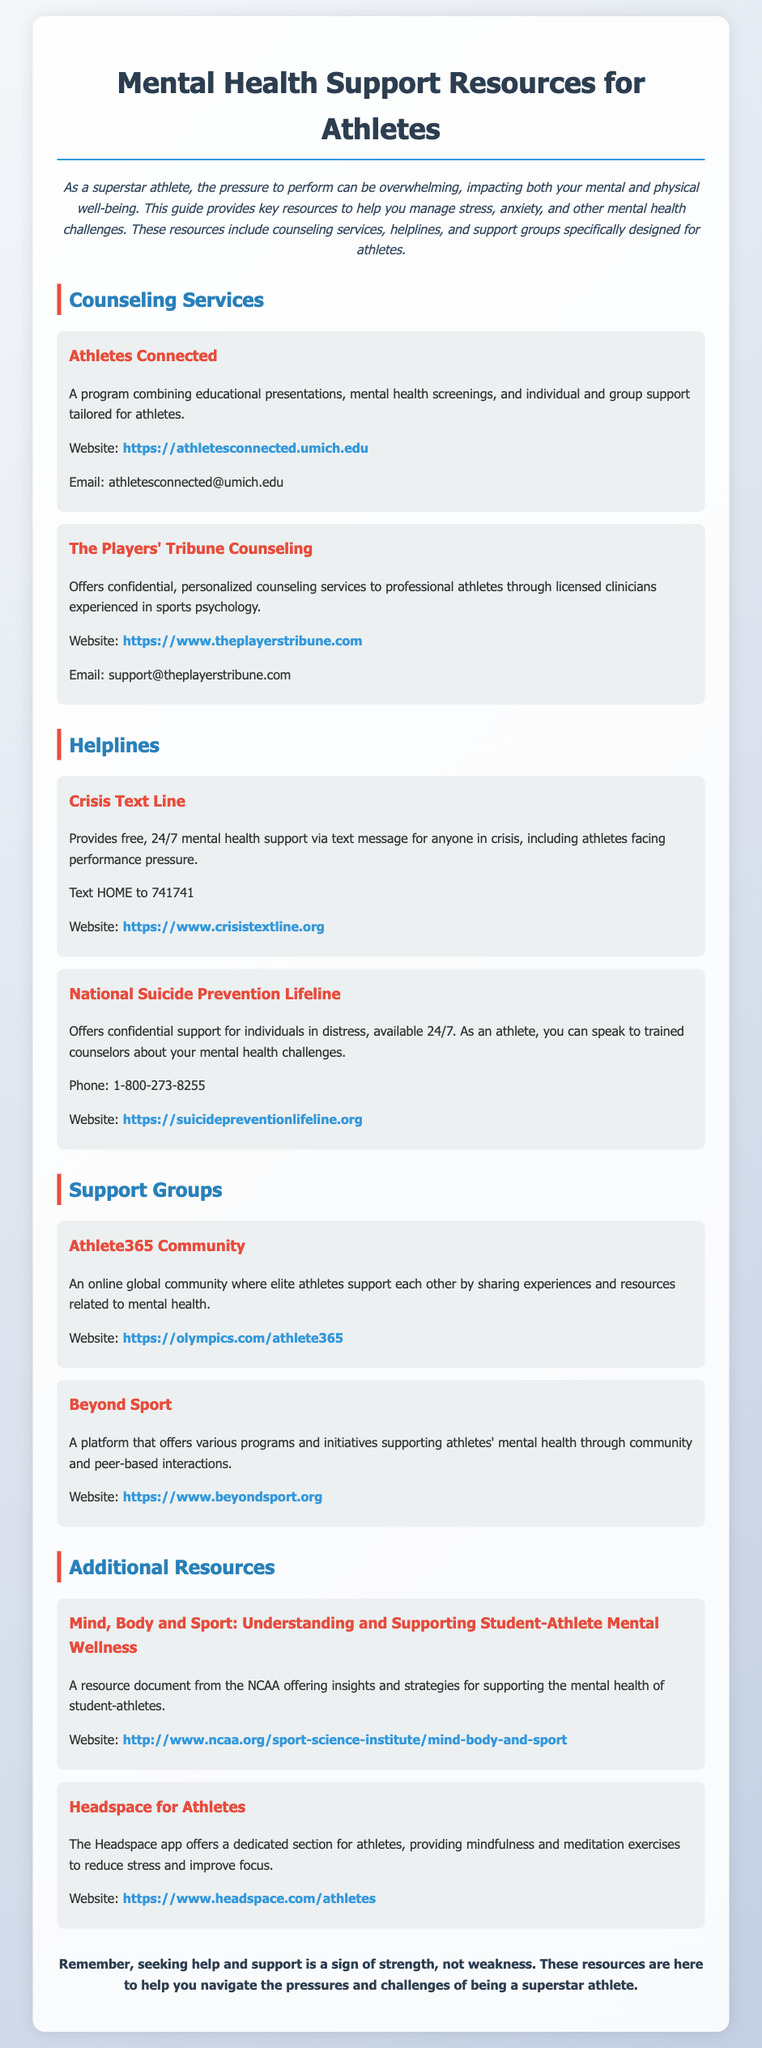what is the name of the program that combines educational presentations and support for athletes? The program focusing on educational presentations and support for athletes is called "Athletes Connected."
Answer: Athletes Connected what is the contact email for The Players' Tribune Counseling? The contact email for the counseling service is provided within the document.
Answer: support@theplayerstribune.com what is the phone number for the National Suicide Prevention Lifeline? The document specifies the phone number for the helpline as part of its support resources.
Answer: 1-800-273-8255 which organization offers a global community for elite athletes? The document mentions an online community platform specifically for elite athletes.
Answer: Athlete365 Community what service does the Crisis Text Line provide? The document describes the Crisis Text Line as offering a specific type of support for individuals in crisis.
Answer: 24/7 mental health support via text message who benefits from the initiative "Mind, Body and Sport"? The initiative mentioned in the document is aimed at a specific group of individuals.
Answer: student-athletes which app provides mindfulness and meditation exercises for athletes? The document lists a specific app tailored for athletes' mental wellness.
Answer: Headspace what color is used for the headings of the resource sections? The document uses a specific color for the headings that signify different sections.
Answer: Blue 